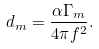<formula> <loc_0><loc_0><loc_500><loc_500>d _ { m } = \frac { \alpha \Gamma _ { m } } { 4 \pi f ^ { 2 } } .</formula> 